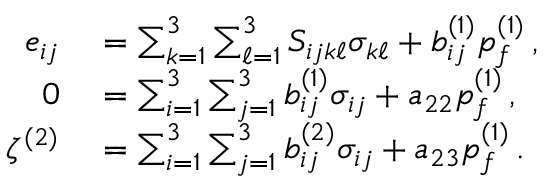<formula> <loc_0><loc_0><loc_500><loc_500>\begin{array} { r l } { e _ { i j } } & = \sum _ { k = 1 } ^ { 3 } \sum _ { \ell = 1 } ^ { 3 } S _ { i j k \ell } \sigma _ { k \ell } + b _ { i j } ^ { ( 1 ) } p _ { f } ^ { ( 1 ) } \, , } \\ { 0 } & = \sum _ { i = 1 } ^ { 3 } \sum _ { j = 1 } ^ { 3 } b _ { i j } ^ { ( 1 ) } \sigma _ { i j } + a _ { 2 2 } p _ { f } ^ { ( 1 ) } \, , } \\ { \zeta ^ { ( 2 ) } } & = \sum _ { i = 1 } ^ { 3 } \sum _ { j = 1 } ^ { 3 } b _ { i j } ^ { ( 2 ) } \sigma _ { i j } + a _ { 2 3 } p _ { f } ^ { ( 1 ) } \, . } \end{array}</formula> 